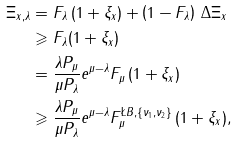Convert formula to latex. <formula><loc_0><loc_0><loc_500><loc_500>\Xi _ { x , \lambda } & = F _ { \lambda } \, ( 1 + \xi _ { x } ) + \left ( 1 - F _ { \lambda } \right ) \, \Delta \Xi _ { x } \\ & \geqslant F _ { \lambda } ( 1 + \xi _ { x } ) \\ & = \frac { \lambda P _ { \mu } } { \mu P _ { \lambda } } e ^ { \mu - \lambda } F _ { \mu } \, ( 1 + \xi _ { x } ) \\ & \geqslant \frac { \lambda P _ { \mu } } { \mu P _ { \lambda } } e ^ { \mu - \lambda } F _ { \mu } ^ { \L B , \{ \nu _ { 1 } , \nu _ { 2 } \} } \, ( 1 + \xi _ { x } ) ,</formula> 